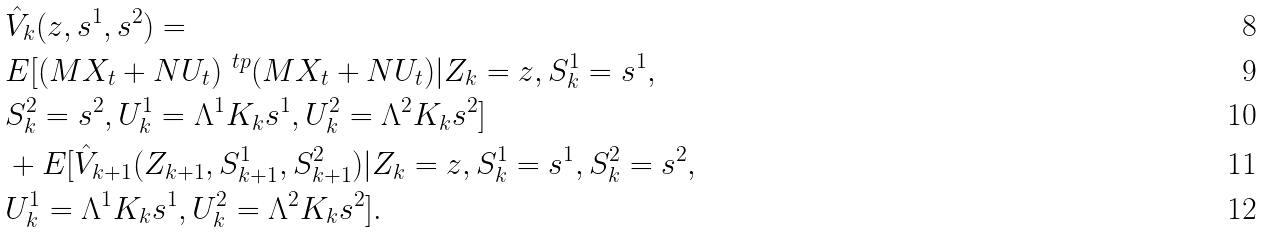Convert formula to latex. <formula><loc_0><loc_0><loc_500><loc_500>& \hat { V } _ { k } ( z , s ^ { 1 } , s ^ { 2 } ) = \\ & E [ ( M X _ { t } + N U _ { t } ) ^ { \ t p } ( M X _ { t } + N U _ { t } ) | Z _ { k } = z , S _ { k } ^ { 1 } = s ^ { 1 } , \\ & S _ { k } ^ { 2 } = s ^ { 2 } , U _ { k } ^ { 1 } = \Lambda ^ { 1 } K _ { k } s ^ { 1 } , U _ { k } ^ { 2 } = \Lambda ^ { 2 } K _ { k } s ^ { 2 } ] \\ & + E [ \hat { V } _ { k + 1 } ( Z _ { k + 1 } , S _ { k + 1 } ^ { 1 } , S _ { k + 1 } ^ { 2 } ) | Z _ { k } = z , S _ { k } ^ { 1 } = s ^ { 1 } , S _ { k } ^ { 2 } = s ^ { 2 } , \\ & U _ { k } ^ { 1 } = \Lambda ^ { 1 } K _ { k } s ^ { 1 } , U _ { k } ^ { 2 } = \Lambda ^ { 2 } K _ { k } s ^ { 2 } ] .</formula> 